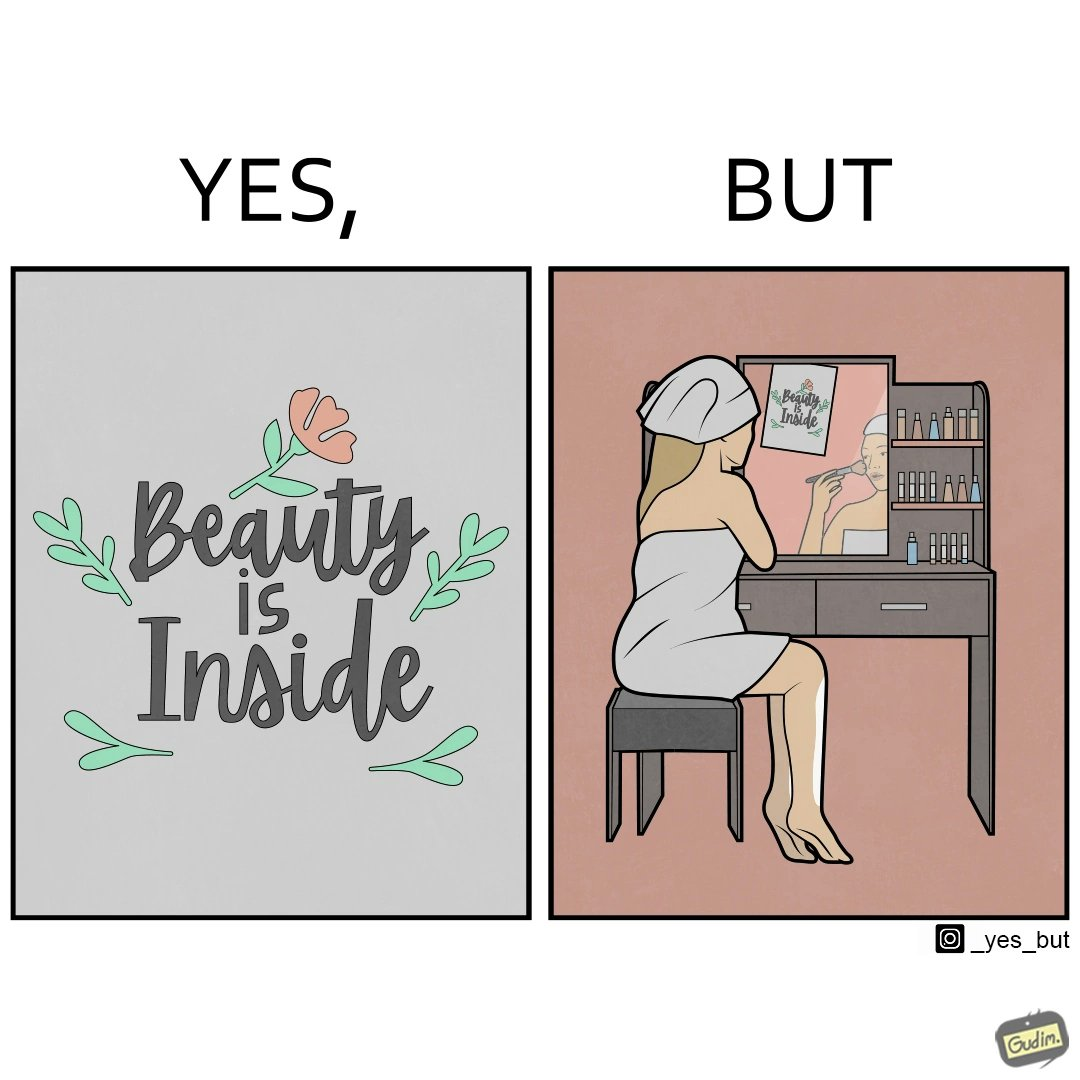Explain the humor or irony in this image. The image is satirical because while the text on the paper says that beauty lies inside, the woman ignores the note and continues to apply makeup to improve her outer beauty. 